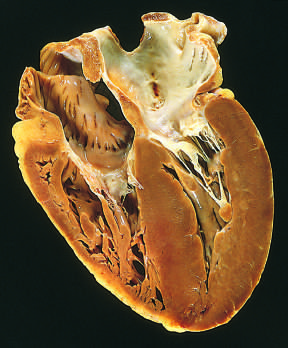s the left ventricle on the lower right in this apical four-chamber view of the heart?
Answer the question using a single word or phrase. Yes 